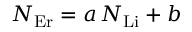<formula> <loc_0><loc_0><loc_500><loc_500>N _ { E r } = a \, N _ { L i } + b</formula> 